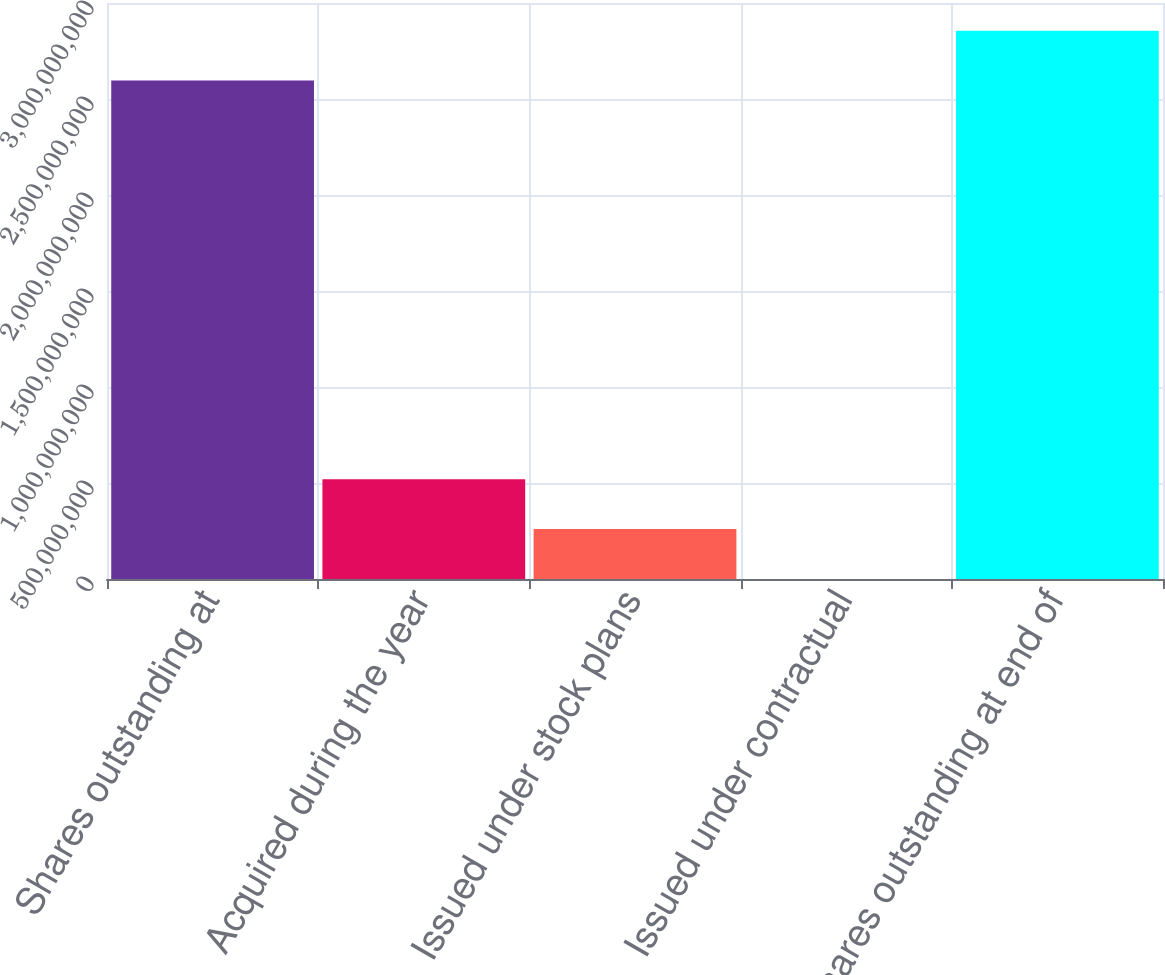<chart> <loc_0><loc_0><loc_500><loc_500><bar_chart><fcel>Shares outstanding at<fcel>Acquired during the year<fcel>Issued under stock plans<fcel>Issued under contractual<fcel>Shares outstanding at end of<nl><fcel>2.59642e+09<fcel>5.19519e+08<fcel>2.59878e+08<fcel>236870<fcel>2.85606e+09<nl></chart> 